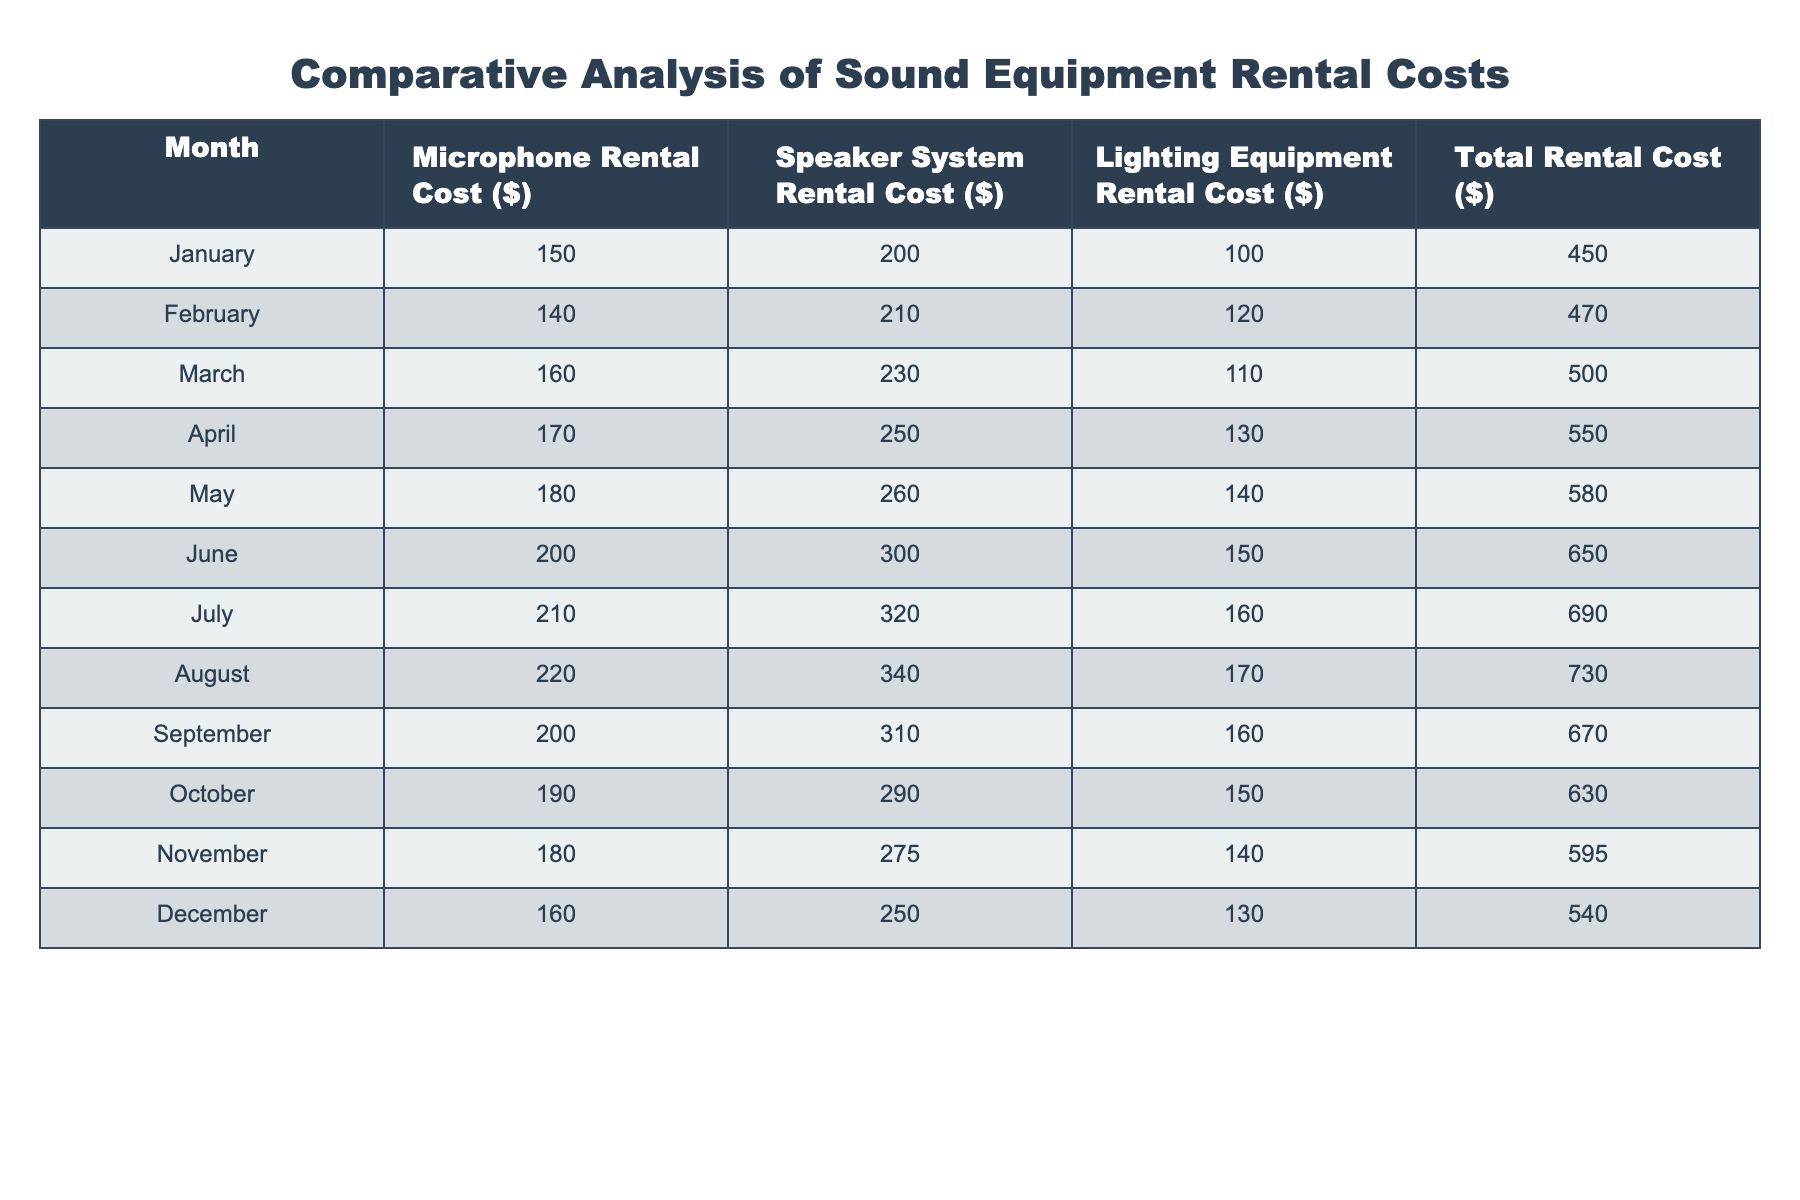What was the total rental cost in June? From the table, the total rental cost listed for June is $650
Answer: 650 What is the difference in microphone rental costs between January and July? In January, the microphone rental cost is $150, while in July it is $210. The difference is $210 - $150 = $60
Answer: 60 Which month had the highest speaker system rental cost? The highest speaker system rental cost can be found in July, which is $320
Answer: July What is the average total rental cost for the year? To find the average, sum all total rental costs: (450 + 470 + 500 + 550 + 580 + 650 + 690 + 730 + 670 + 630 + 595 + 540) = 6,215. There are 12 months, so the average is 6,215 / 12 = 518.75
Answer: 518.75 Was the lighting equipment rental cost higher in August than in May? In August, the lighting equipment rental cost is $170, and in May, it is $140. Since $170 > $140, the statement is true
Answer: Yes How much did the microphone rental cost decrease from August to December? In August, the microphone rental cost is $220, and in December, it is $160. The decrease is $220 - $160 = $60
Answer: 60 Which month had the lowest total rental cost? The lowest total rental cost is found in January, which is $450
Answer: January What was the percentage increase in the speaker system rental cost from October to July? The speaker system rental cost in July is $320 and in October is $290. The increase is $320 - $290 = $30. To find the percentage increase: (30 / 290) * 100 = 10.34%
Answer: 10.34% How many months had a total rental cost above $600? Upon reviewing the table, the months with total rental costs above $600 are June, July, and August, totaling 3 months
Answer: 3 What is the total cost for lighting equipment in the first half of the year? For the first half of the year, the costs are: January ($100) + February ($120) + March ($110) + April ($130) + May ($140) + June ($150) = $750
Answer: 750 